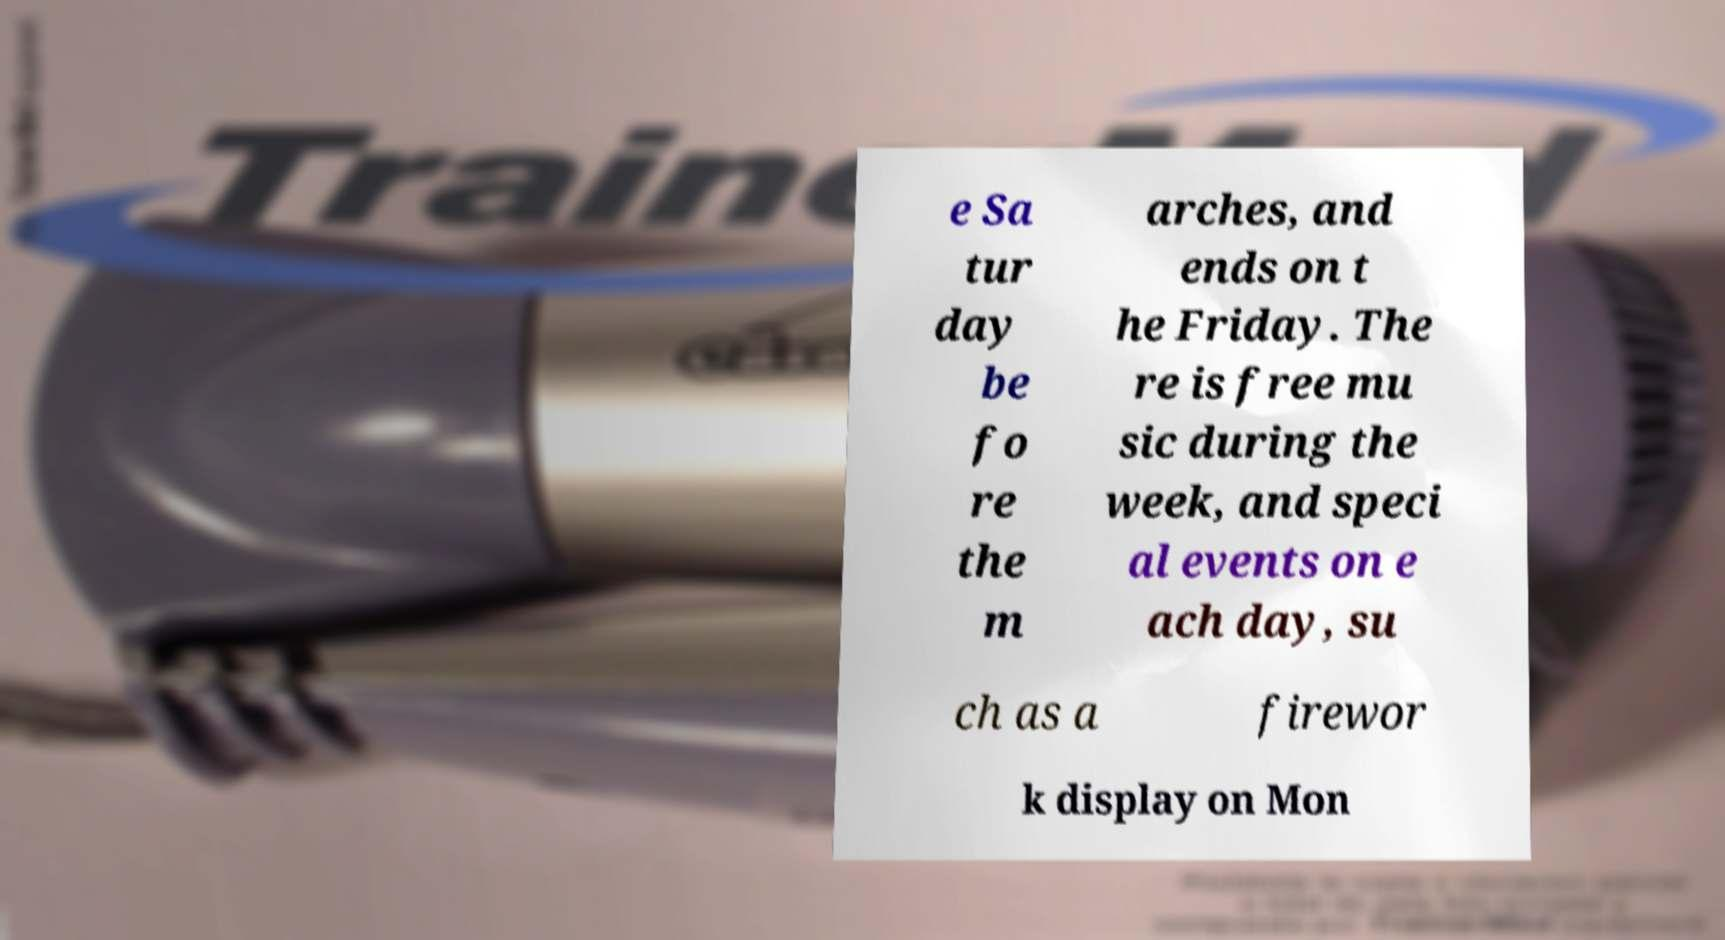What messages or text are displayed in this image? I need them in a readable, typed format. e Sa tur day be fo re the m arches, and ends on t he Friday. The re is free mu sic during the week, and speci al events on e ach day, su ch as a firewor k display on Mon 